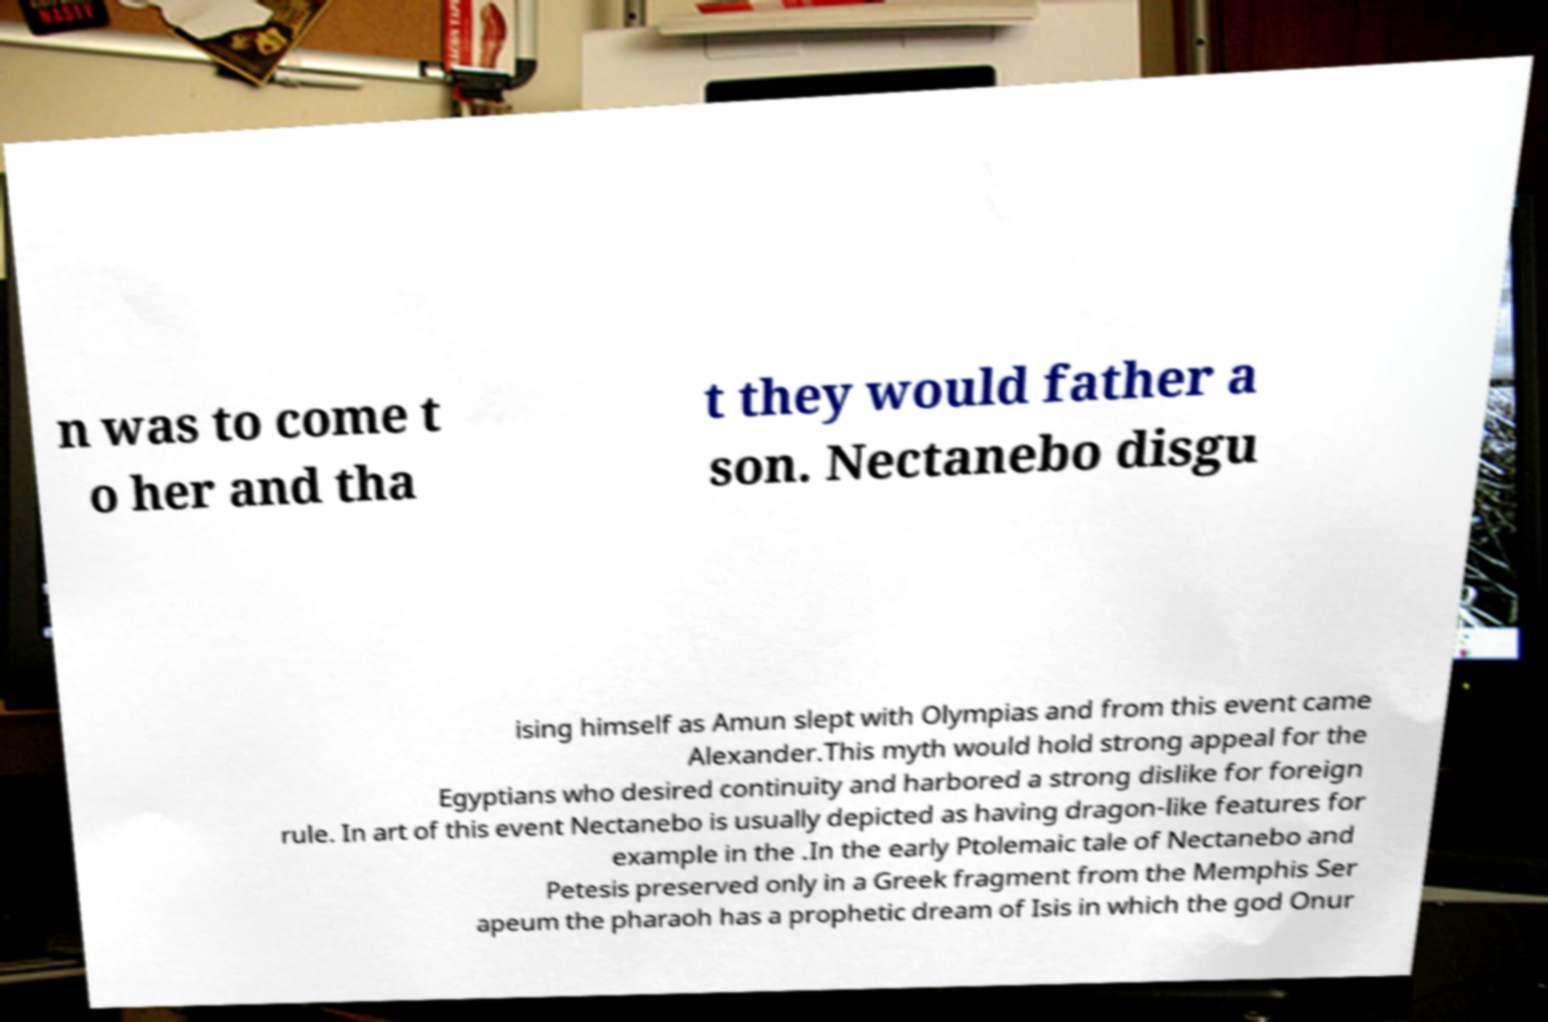Please identify and transcribe the text found in this image. n was to come t o her and tha t they would father a son. Nectanebo disgu ising himself as Amun slept with Olympias and from this event came Alexander.This myth would hold strong appeal for the Egyptians who desired continuity and harbored a strong dislike for foreign rule. In art of this event Nectanebo is usually depicted as having dragon-like features for example in the .In the early Ptolemaic tale of Nectanebo and Petesis preserved only in a Greek fragment from the Memphis Ser apeum the pharaoh has a prophetic dream of Isis in which the god Onur 